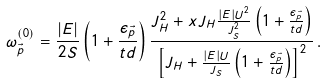Convert formula to latex. <formula><loc_0><loc_0><loc_500><loc_500>\omega ^ { ( 0 ) } _ { \vec { p } } = \frac { | E | } { 2 S } \left ( 1 + \frac { \epsilon _ { \vec { p } } } { t d } \right ) \frac { J _ { H } ^ { 2 } + x J _ { H } \frac { | E | U ^ { 2 } } { J _ { S } ^ { 2 } } \left ( 1 + \frac { \epsilon _ { \vec { p } } } { t d } \right ) } { \left [ J _ { H } + \frac { | E | U } { J _ { S } } \left ( 1 + \frac { \epsilon _ { \vec { p } } } { t d } \right ) \right ] ^ { 2 } } \, .</formula> 